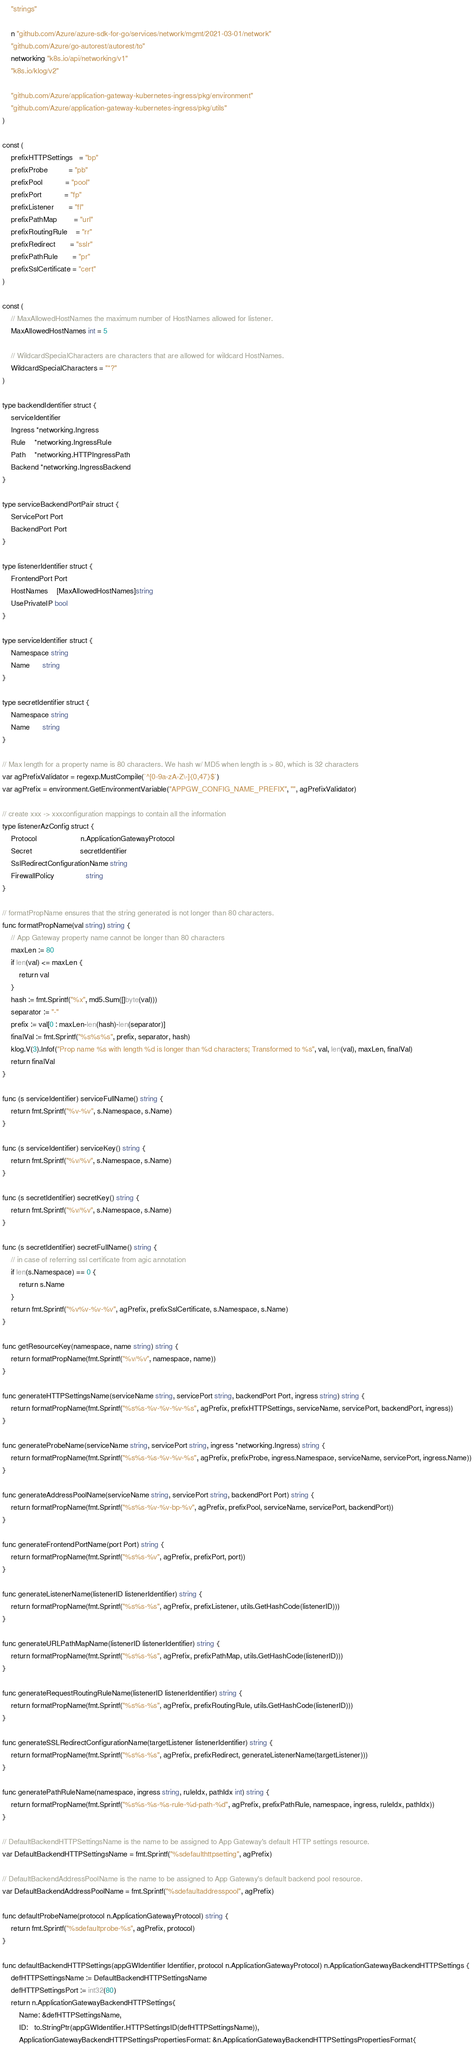<code> <loc_0><loc_0><loc_500><loc_500><_Go_>	"strings"

	n "github.com/Azure/azure-sdk-for-go/services/network/mgmt/2021-03-01/network"
	"github.com/Azure/go-autorest/autorest/to"
	networking "k8s.io/api/networking/v1"
	"k8s.io/klog/v2"

	"github.com/Azure/application-gateway-kubernetes-ingress/pkg/environment"
	"github.com/Azure/application-gateway-kubernetes-ingress/pkg/utils"
)

const (
	prefixHTTPSettings   = "bp"
	prefixProbe          = "pb"
	prefixPool           = "pool"
	prefixPort           = "fp"
	prefixListener       = "fl"
	prefixPathMap        = "url"
	prefixRoutingRule    = "rr"
	prefixRedirect       = "sslr"
	prefixPathRule       = "pr"
	prefixSslCertificate = "cert"
)

const (
	// MaxAllowedHostNames the maximum number of HostNames allowed for listener.
	MaxAllowedHostNames int = 5

	// WildcardSpecialCharacters are characters that are allowed for wildcard HostNames.
	WildcardSpecialCharacters = "*?"
)

type backendIdentifier struct {
	serviceIdentifier
	Ingress *networking.Ingress
	Rule    *networking.IngressRule
	Path    *networking.HTTPIngressPath
	Backend *networking.IngressBackend
}

type serviceBackendPortPair struct {
	ServicePort Port
	BackendPort Port
}

type listenerIdentifier struct {
	FrontendPort Port
	HostNames    [MaxAllowedHostNames]string
	UsePrivateIP bool
}

type serviceIdentifier struct {
	Namespace string
	Name      string
}

type secretIdentifier struct {
	Namespace string
	Name      string
}

// Max length for a property name is 80 characters. We hash w/ MD5 when length is > 80, which is 32 characters
var agPrefixValidator = regexp.MustCompile(`^[0-9a-zA-Z\-]{0,47}$`)
var agPrefix = environment.GetEnvironmentVariable("APPGW_CONFIG_NAME_PREFIX", "", agPrefixValidator)

// create xxx -> xxxconfiguration mappings to contain all the information
type listenerAzConfig struct {
	Protocol                     n.ApplicationGatewayProtocol
	Secret                       secretIdentifier
	SslRedirectConfigurationName string
	FirewallPolicy               string
}

// formatPropName ensures that the string generated is not longer than 80 characters.
func formatPropName(val string) string {
	// App Gateway property name cannot be longer than 80 characters
	maxLen := 80
	if len(val) <= maxLen {
		return val
	}
	hash := fmt.Sprintf("%x", md5.Sum([]byte(val)))
	separator := "-"
	prefix := val[0 : maxLen-len(hash)-len(separator)]
	finalVal := fmt.Sprintf("%s%s%s", prefix, separator, hash)
	klog.V(3).Infof("Prop name %s with length %d is longer than %d characters; Transformed to %s", val, len(val), maxLen, finalVal)
	return finalVal
}

func (s serviceIdentifier) serviceFullName() string {
	return fmt.Sprintf("%v-%v", s.Namespace, s.Name)
}

func (s serviceIdentifier) serviceKey() string {
	return fmt.Sprintf("%v/%v", s.Namespace, s.Name)
}

func (s secretIdentifier) secretKey() string {
	return fmt.Sprintf("%v/%v", s.Namespace, s.Name)
}

func (s secretIdentifier) secretFullName() string {
	// in case of referring ssl certificate from agic annotation
	if len(s.Namespace) == 0 {
		return s.Name
	}
	return fmt.Sprintf("%v%v-%v-%v", agPrefix, prefixSslCertificate, s.Namespace, s.Name)
}

func getResourceKey(namespace, name string) string {
	return formatPropName(fmt.Sprintf("%v/%v", namespace, name))
}

func generateHTTPSettingsName(serviceName string, servicePort string, backendPort Port, ingress string) string {
	return formatPropName(fmt.Sprintf("%s%s-%v-%v-%v-%s", agPrefix, prefixHTTPSettings, serviceName, servicePort, backendPort, ingress))
}

func generateProbeName(serviceName string, servicePort string, ingress *networking.Ingress) string {
	return formatPropName(fmt.Sprintf("%s%s-%s-%v-%v-%s", agPrefix, prefixProbe, ingress.Namespace, serviceName, servicePort, ingress.Name))
}

func generateAddressPoolName(serviceName string, servicePort string, backendPort Port) string {
	return formatPropName(fmt.Sprintf("%s%s-%v-%v-bp-%v", agPrefix, prefixPool, serviceName, servicePort, backendPort))
}

func generateFrontendPortName(port Port) string {
	return formatPropName(fmt.Sprintf("%s%s-%v", agPrefix, prefixPort, port))
}

func generateListenerName(listenerID listenerIdentifier) string {
	return formatPropName(fmt.Sprintf("%s%s-%s", agPrefix, prefixListener, utils.GetHashCode(listenerID)))
}

func generateURLPathMapName(listenerID listenerIdentifier) string {
	return formatPropName(fmt.Sprintf("%s%s-%s", agPrefix, prefixPathMap, utils.GetHashCode(listenerID)))
}

func generateRequestRoutingRuleName(listenerID listenerIdentifier) string {
	return formatPropName(fmt.Sprintf("%s%s-%s", agPrefix, prefixRoutingRule, utils.GetHashCode(listenerID)))
}

func generateSSLRedirectConfigurationName(targetListener listenerIdentifier) string {
	return formatPropName(fmt.Sprintf("%s%s-%s", agPrefix, prefixRedirect, generateListenerName(targetListener)))
}

func generatePathRuleName(namespace, ingress string, ruleIdx, pathIdx int) string {
	return formatPropName(fmt.Sprintf("%s%s-%s-%s-rule-%d-path-%d", agPrefix, prefixPathRule, namespace, ingress, ruleIdx, pathIdx))
}

// DefaultBackendHTTPSettingsName is the name to be assigned to App Gateway's default HTTP settings resource.
var DefaultBackendHTTPSettingsName = fmt.Sprintf("%sdefaulthttpsetting", agPrefix)

// DefaultBackendAddressPoolName is the name to be assigned to App Gateway's default backend pool resource.
var DefaultBackendAddressPoolName = fmt.Sprintf("%sdefaultaddresspool", agPrefix)

func defaultProbeName(protocol n.ApplicationGatewayProtocol) string {
	return fmt.Sprintf("%sdefaultprobe-%s", agPrefix, protocol)
}

func defaultBackendHTTPSettings(appGWIdentifier Identifier, protocol n.ApplicationGatewayProtocol) n.ApplicationGatewayBackendHTTPSettings {
	defHTTPSettingsName := DefaultBackendHTTPSettingsName
	defHTTPSettingsPort := int32(80)
	return n.ApplicationGatewayBackendHTTPSettings{
		Name: &defHTTPSettingsName,
		ID:   to.StringPtr(appGWIdentifier.HTTPSettingsID(defHTTPSettingsName)),
		ApplicationGatewayBackendHTTPSettingsPropertiesFormat: &n.ApplicationGatewayBackendHTTPSettingsPropertiesFormat{</code> 